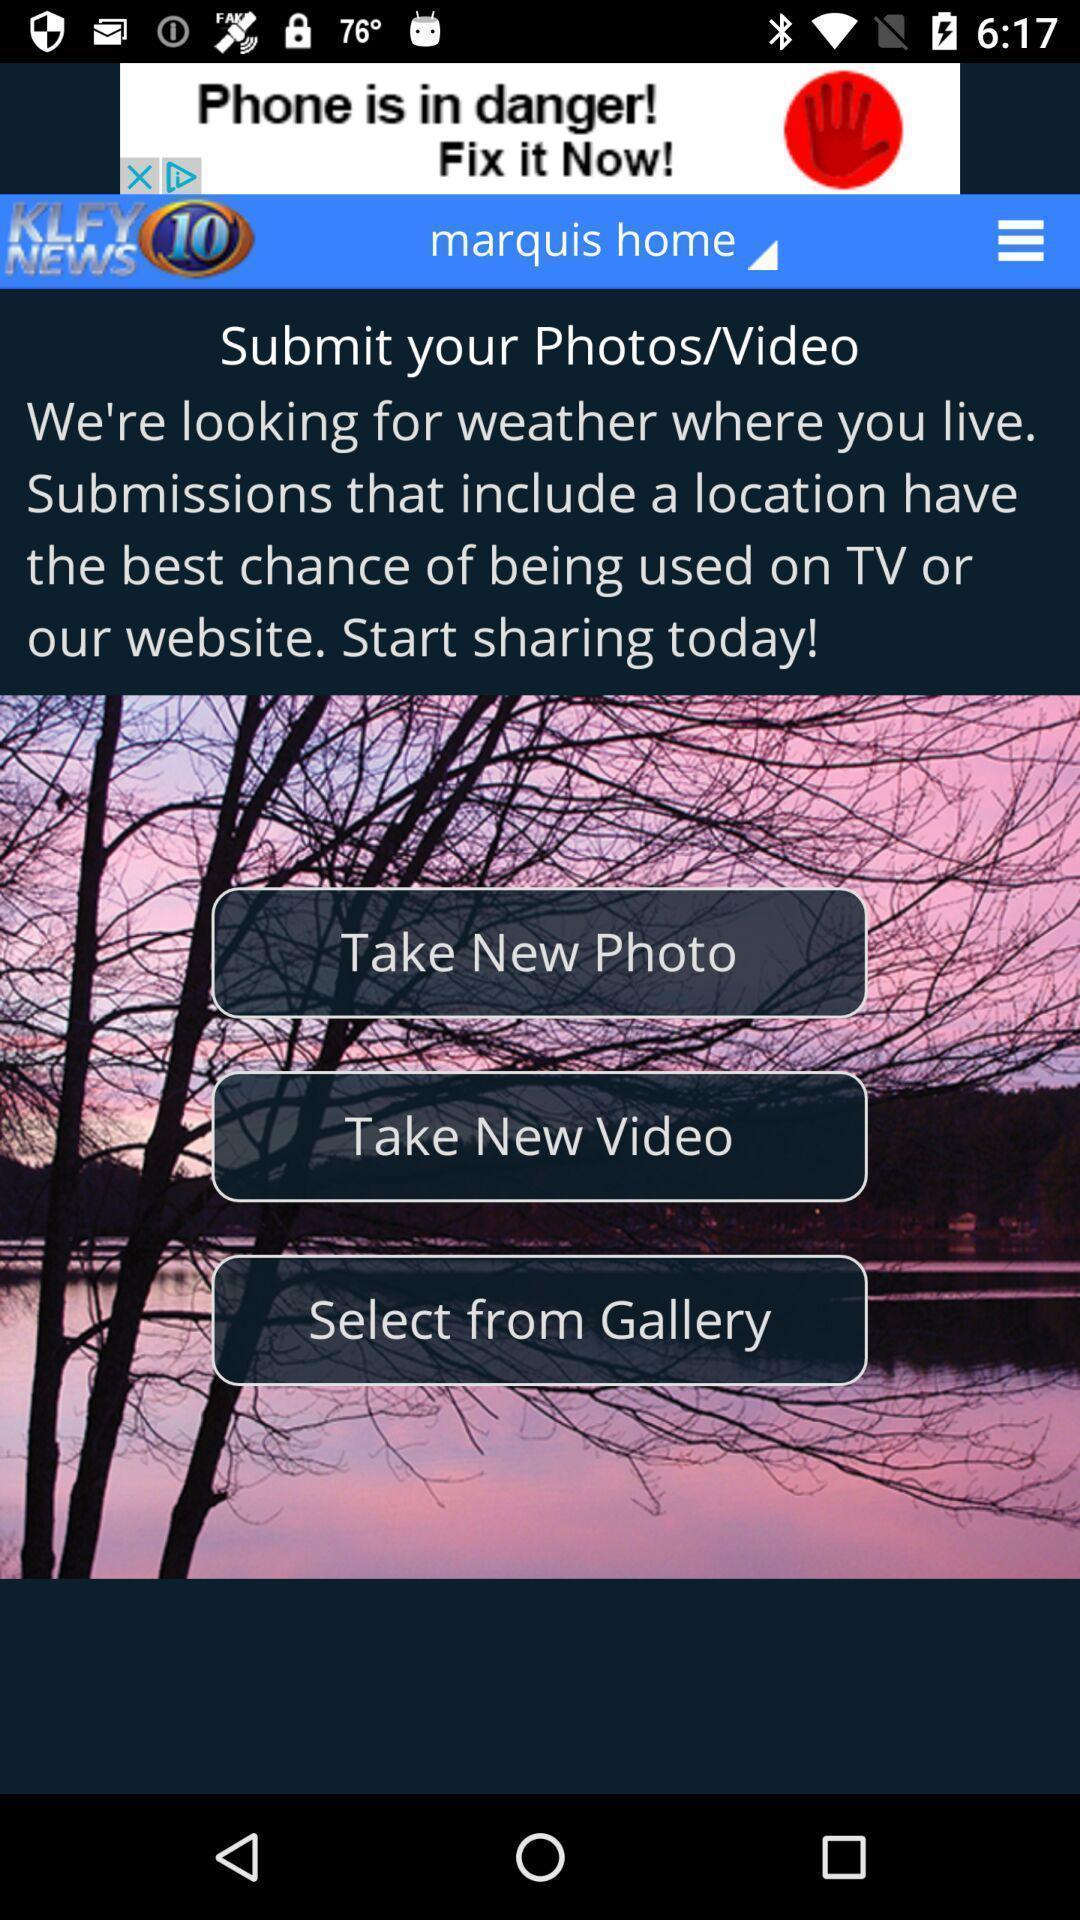Explain what's happening in this screen capture. Screen shows multiple options in a weather application. 